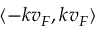<formula> <loc_0><loc_0><loc_500><loc_500>\langle - k v _ { F } , k v _ { F } \rangle</formula> 